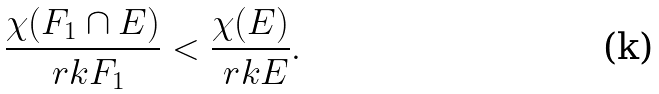Convert formula to latex. <formula><loc_0><loc_0><loc_500><loc_500>\frac { \chi ( F _ { 1 } \cap E ) } { \ r k F _ { 1 } } < \frac { \chi ( E ) } { \ r k E } .</formula> 